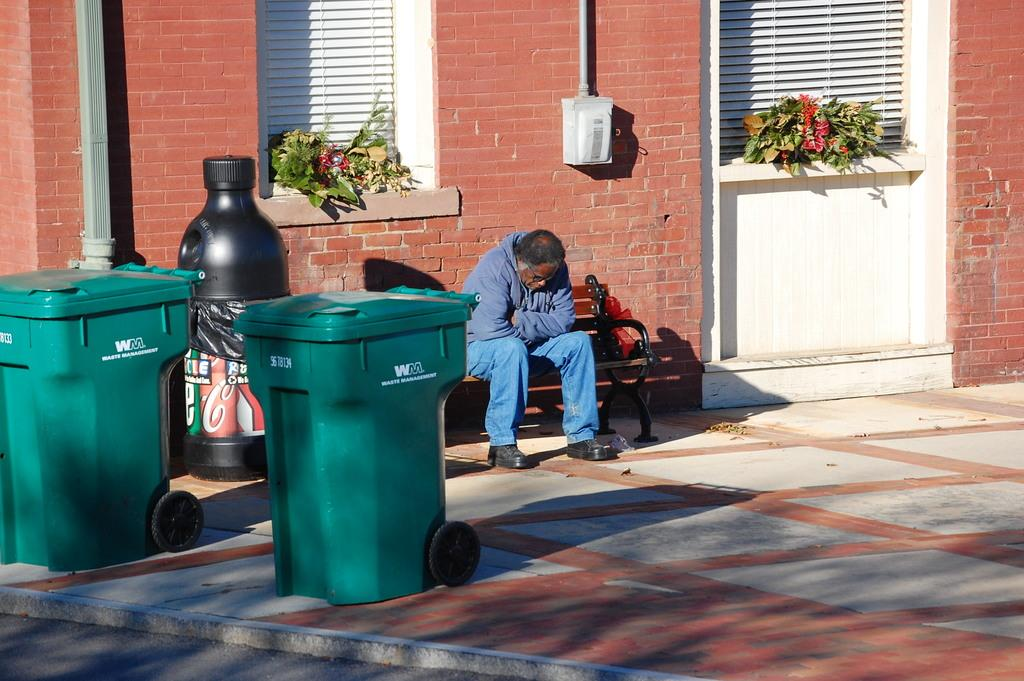<image>
Describe the image concisely. A man sits on a bench near two green, WM labeled trash cans. 